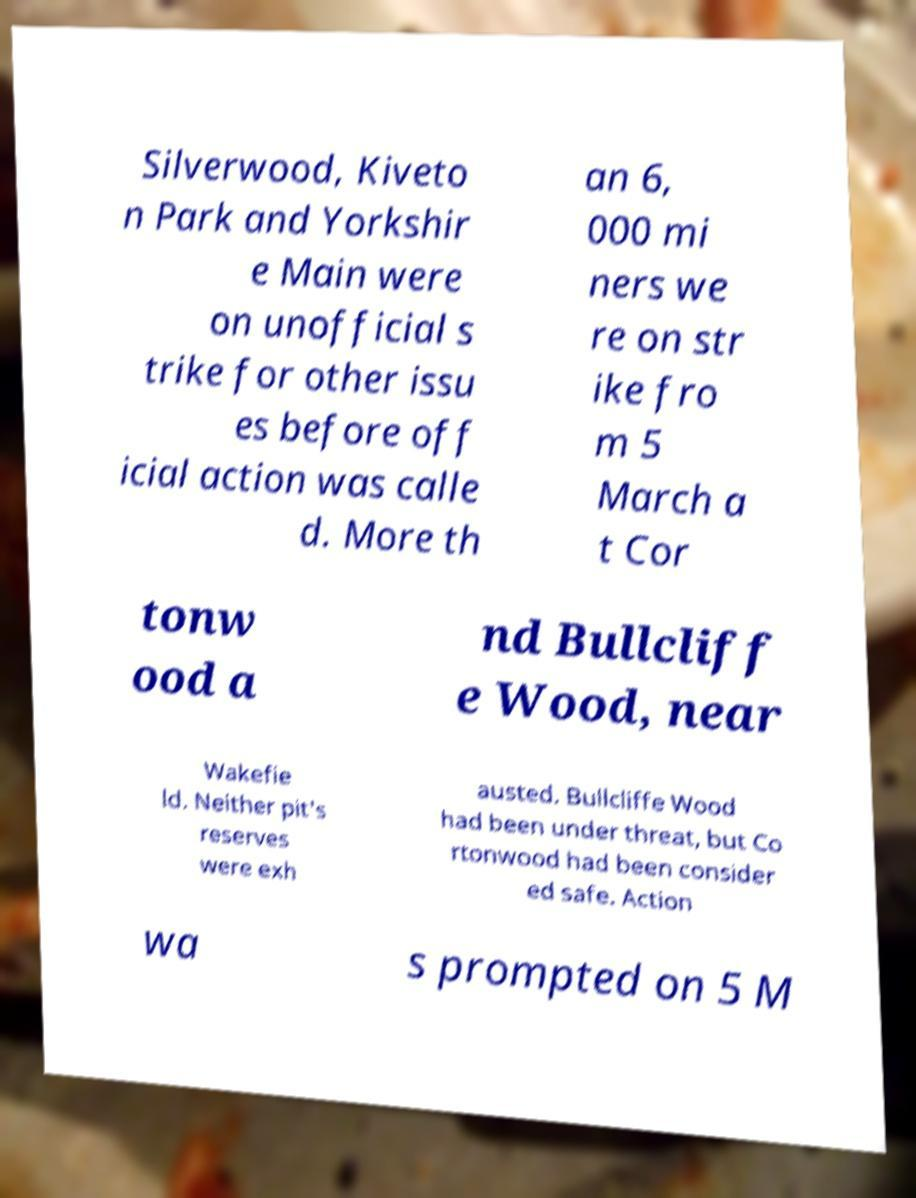For documentation purposes, I need the text within this image transcribed. Could you provide that? Silverwood, Kiveto n Park and Yorkshir e Main were on unofficial s trike for other issu es before off icial action was calle d. More th an 6, 000 mi ners we re on str ike fro m 5 March a t Cor tonw ood a nd Bullcliff e Wood, near Wakefie ld. Neither pit's reserves were exh austed. Bullcliffe Wood had been under threat, but Co rtonwood had been consider ed safe. Action wa s prompted on 5 M 